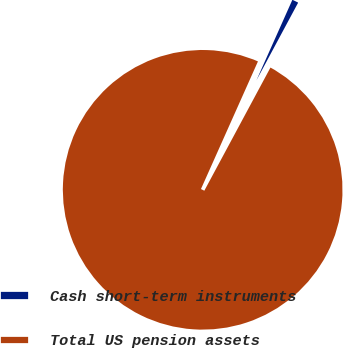Convert chart to OTSL. <chart><loc_0><loc_0><loc_500><loc_500><pie_chart><fcel>Cash short-term instruments<fcel>Total US pension assets<nl><fcel>1.16%<fcel>98.84%<nl></chart> 